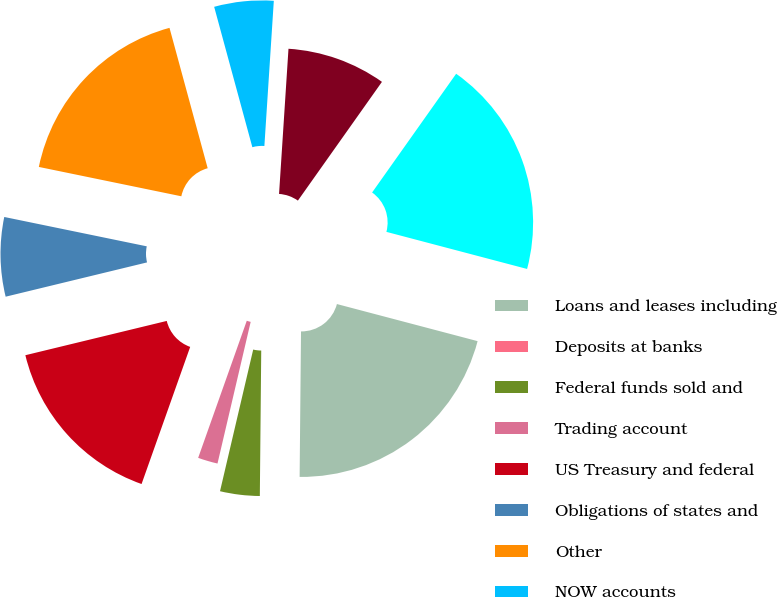<chart> <loc_0><loc_0><loc_500><loc_500><pie_chart><fcel>Loans and leases including<fcel>Deposits at banks<fcel>Federal funds sold and<fcel>Trading account<fcel>US Treasury and federal<fcel>Obligations of states and<fcel>Other<fcel>NOW accounts<fcel>Savings deposits<fcel>Time deposits<nl><fcel>21.05%<fcel>0.0%<fcel>3.51%<fcel>1.76%<fcel>15.79%<fcel>7.02%<fcel>17.54%<fcel>5.26%<fcel>8.77%<fcel>19.3%<nl></chart> 